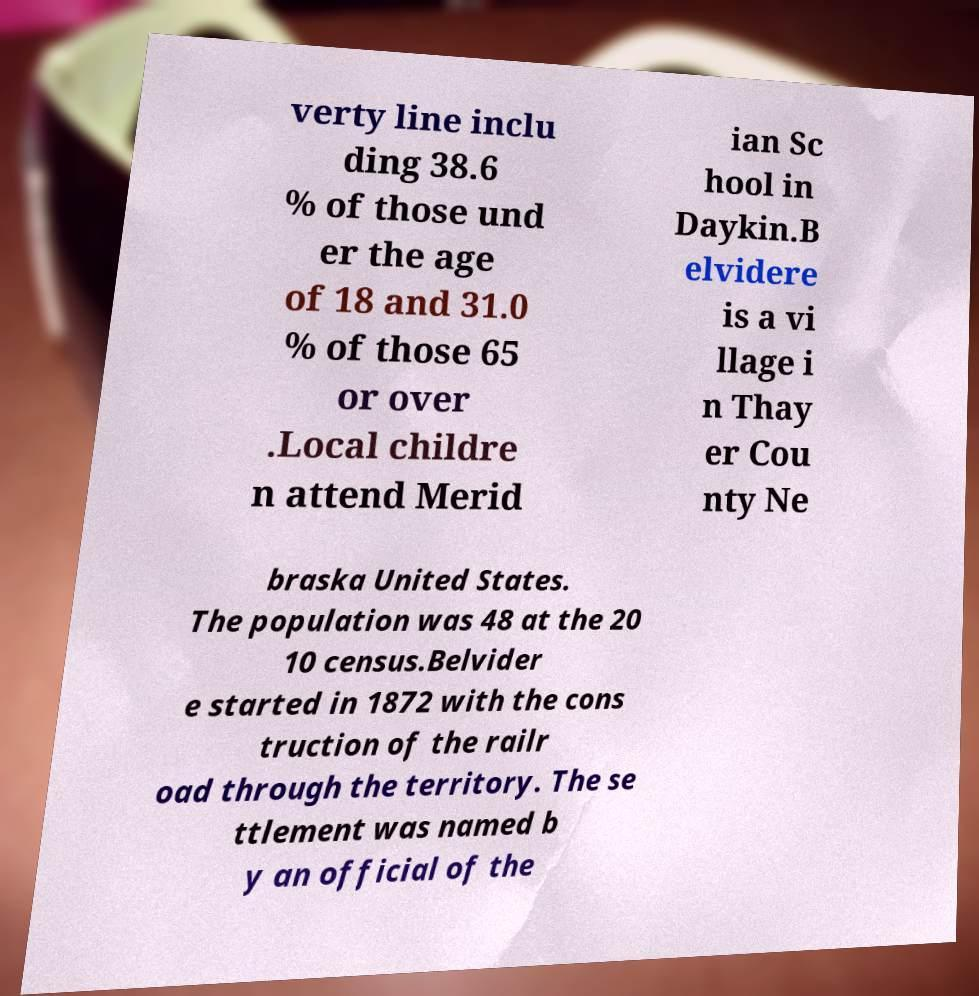Please identify and transcribe the text found in this image. verty line inclu ding 38.6 % of those und er the age of 18 and 31.0 % of those 65 or over .Local childre n attend Merid ian Sc hool in Daykin.B elvidere is a vi llage i n Thay er Cou nty Ne braska United States. The population was 48 at the 20 10 census.Belvider e started in 1872 with the cons truction of the railr oad through the territory. The se ttlement was named b y an official of the 